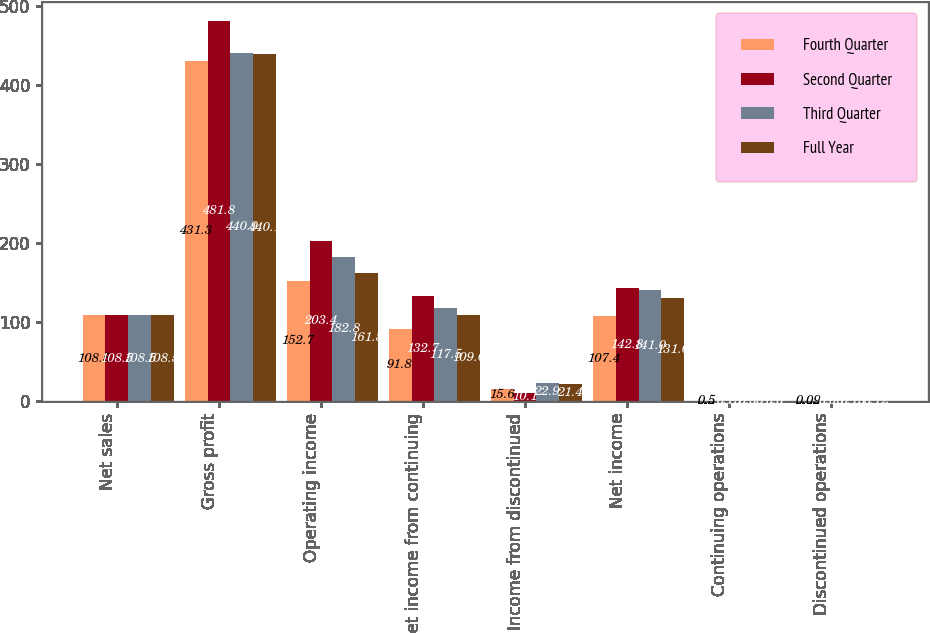Convert chart to OTSL. <chart><loc_0><loc_0><loc_500><loc_500><stacked_bar_chart><ecel><fcel>Net sales<fcel>Gross profit<fcel>Operating income<fcel>Net income from continuing<fcel>Income from discontinued<fcel>Net income<fcel>Continuing operations<fcel>Discontinued operations<nl><fcel>Fourth Quarter<fcel>108.5<fcel>431.3<fcel>152.7<fcel>91.8<fcel>15.6<fcel>107.4<fcel>0.5<fcel>0.09<nl><fcel>Second Quarter<fcel>108.5<fcel>481.8<fcel>203.4<fcel>132.7<fcel>10.1<fcel>142.8<fcel>0.73<fcel>0.06<nl><fcel>Third Quarter<fcel>108.5<fcel>440.9<fcel>182.8<fcel>117.5<fcel>22.9<fcel>141<fcel>0.65<fcel>0.13<nl><fcel>Full Year<fcel>108.5<fcel>440.1<fcel>161.8<fcel>109.6<fcel>21.4<fcel>131<fcel>0.6<fcel>0.12<nl></chart> 